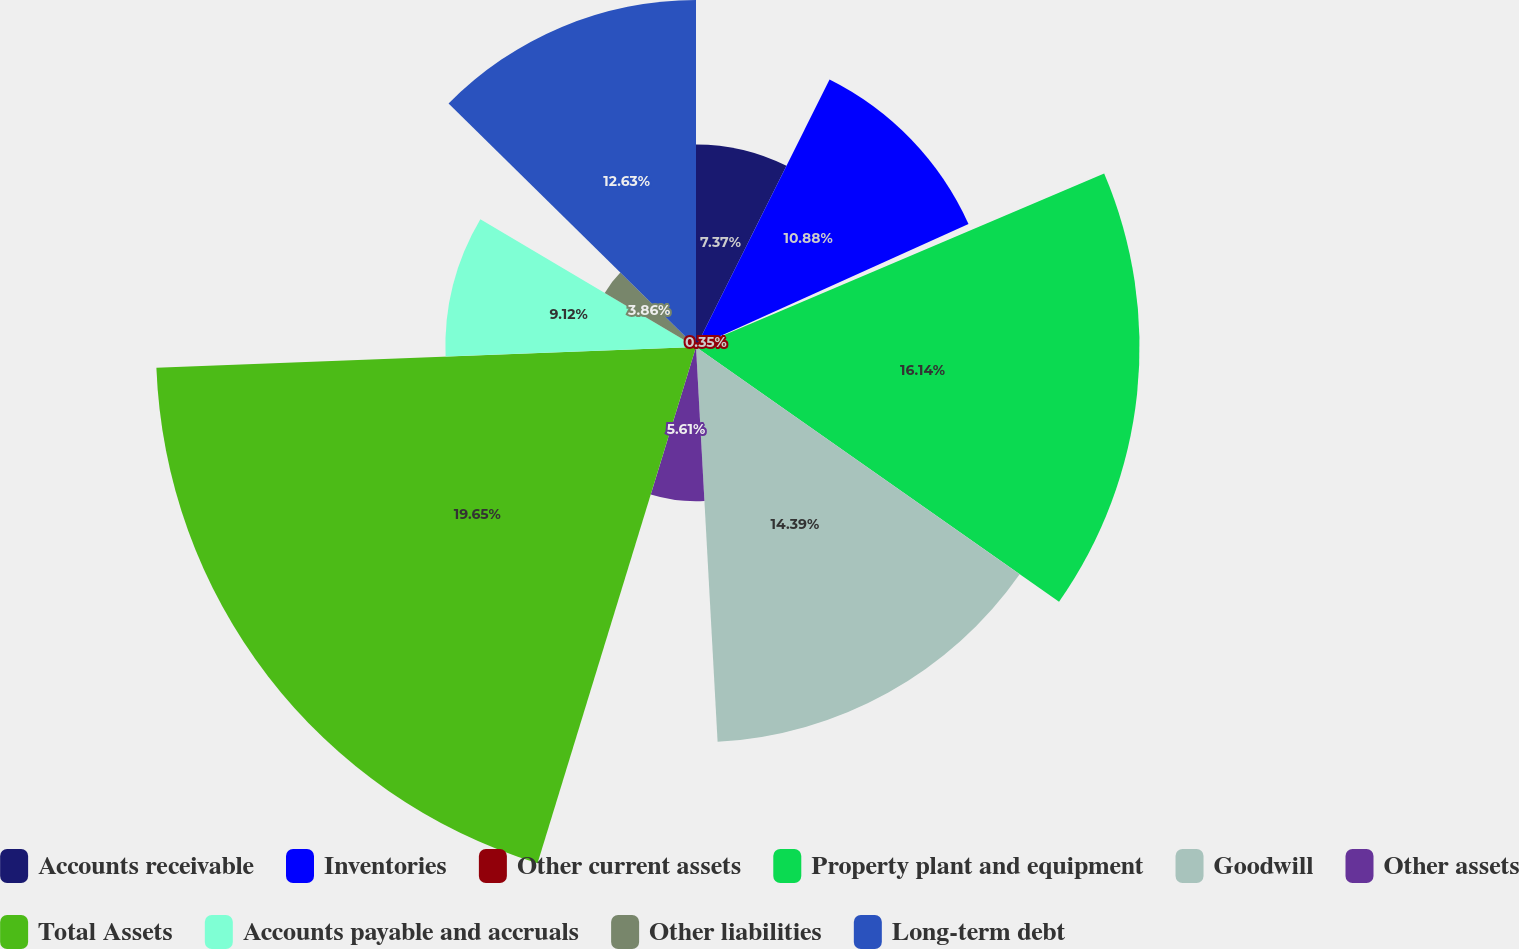<chart> <loc_0><loc_0><loc_500><loc_500><pie_chart><fcel>Accounts receivable<fcel>Inventories<fcel>Other current assets<fcel>Property plant and equipment<fcel>Goodwill<fcel>Other assets<fcel>Total Assets<fcel>Accounts payable and accruals<fcel>Other liabilities<fcel>Long-term debt<nl><fcel>7.37%<fcel>10.88%<fcel>0.35%<fcel>16.14%<fcel>14.39%<fcel>5.61%<fcel>19.65%<fcel>9.12%<fcel>3.86%<fcel>12.63%<nl></chart> 